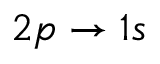<formula> <loc_0><loc_0><loc_500><loc_500>2 p \rightarrow 1 s</formula> 